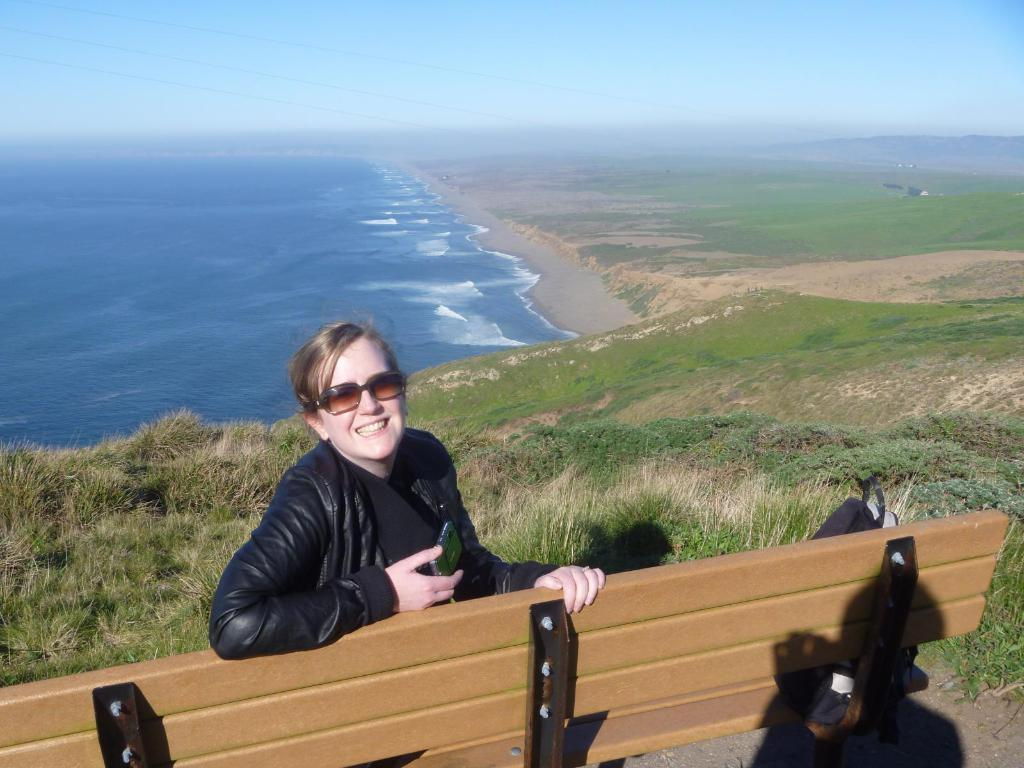What is the woman in the image doing? The woman is sitting on a bench in the image. What is the woman wearing on her upper body? The woman is wearing a black jacket. What type of eyewear is the woman wearing? The woman is wearing sunglasses. What can be seen in the background of the image? There is water visible in the image. What type of ground is present in the image? The ground is covered with grass. What type of discussion is the woman having with the kitten in the image? There is no kitten present in the image, and therefore no discussion can be observed. What type of celery is the woman holding in the image? There is no celery present in the image. 